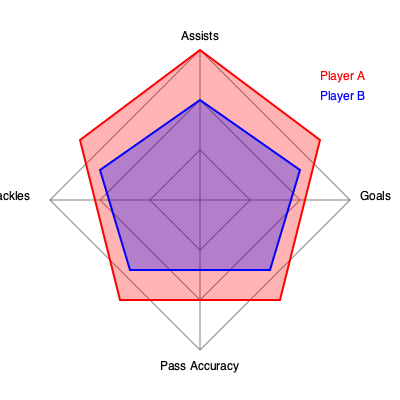Based on the radar chart comparing two Premier League players, which player appears to have a more balanced overall performance across the four metrics shown? To determine which player has a more balanced overall performance, we need to analyze the radar chart for both players across the four metrics: Goals, Assists, Tackles, and Pass Accuracy.

Step 1: Identify the players
- Player A is represented by the red polygon
- Player B is represented by the blue polygon

Step 2: Compare the shapes of the polygons
- A more balanced performance would result in a more regular (square-like) shape
- An unbalanced performance would show significant peaks and valleys

Step 3: Analyze Player A's performance
- Strong in Goals and Assists (extends to outer areas)
- Relatively weak in Tackles and Pass Accuracy (doesn't extend as far)
- Creates an irregular, elongated shape

Step 4: Analyze Player B's performance
- Moderate performance across all four metrics
- Creates a more regular, square-like shape

Step 5: Compare the balance of performances
- Player A shows high variability across metrics (unbalanced)
- Player B shows more consistency across all metrics (balanced)

Therefore, based on the radar chart, Player B demonstrates a more balanced overall performance across the four metrics shown.
Answer: Player B 